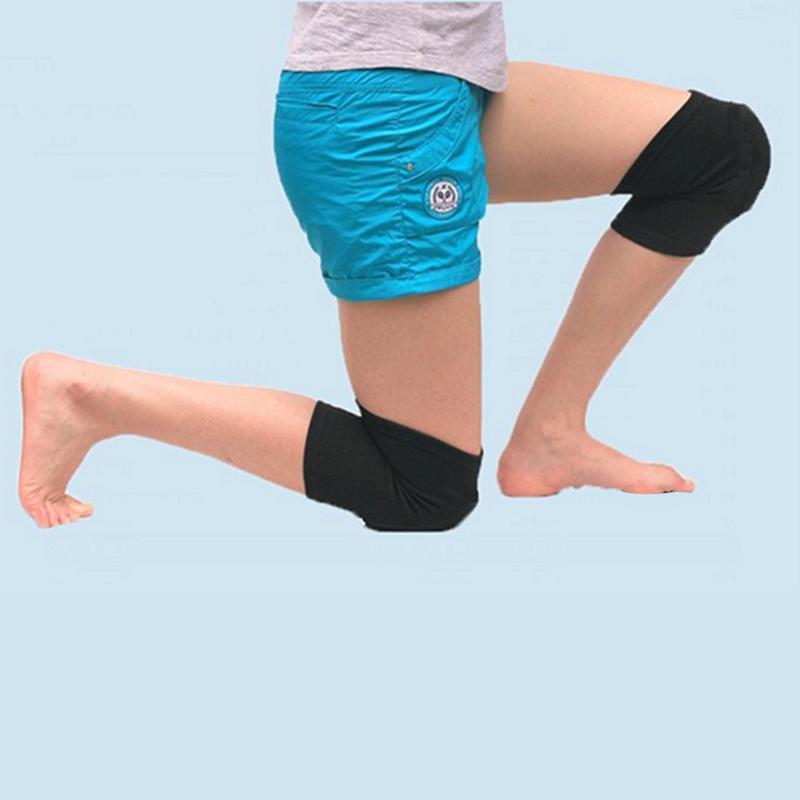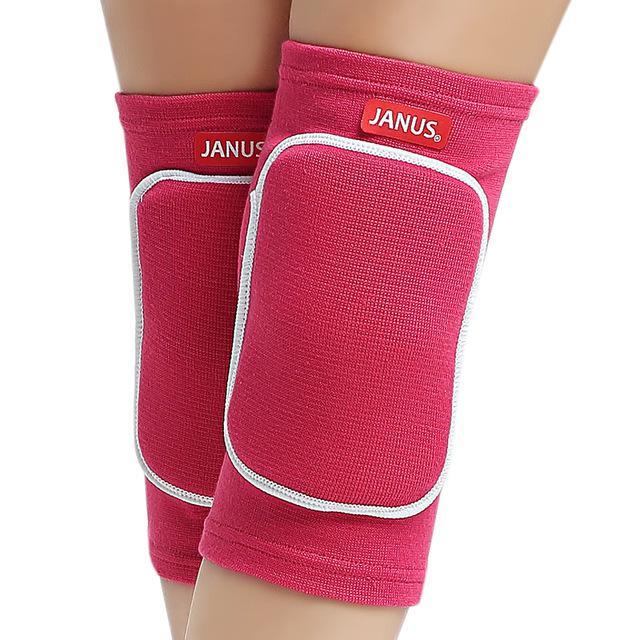The first image is the image on the left, the second image is the image on the right. Examine the images to the left and right. Is the description "Each image includes a rightward-bent knee in a hot pink knee pad." accurate? Answer yes or no. No. 